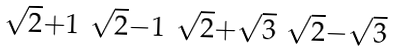Convert formula to latex. <formula><loc_0><loc_0><loc_500><loc_500>\begin{smallmatrix} \sqrt { 2 } + 1 & \sqrt { 2 } - 1 & \sqrt { 2 } + \sqrt { 3 } & \sqrt { 2 } - \sqrt { 3 } \end{smallmatrix}</formula> 